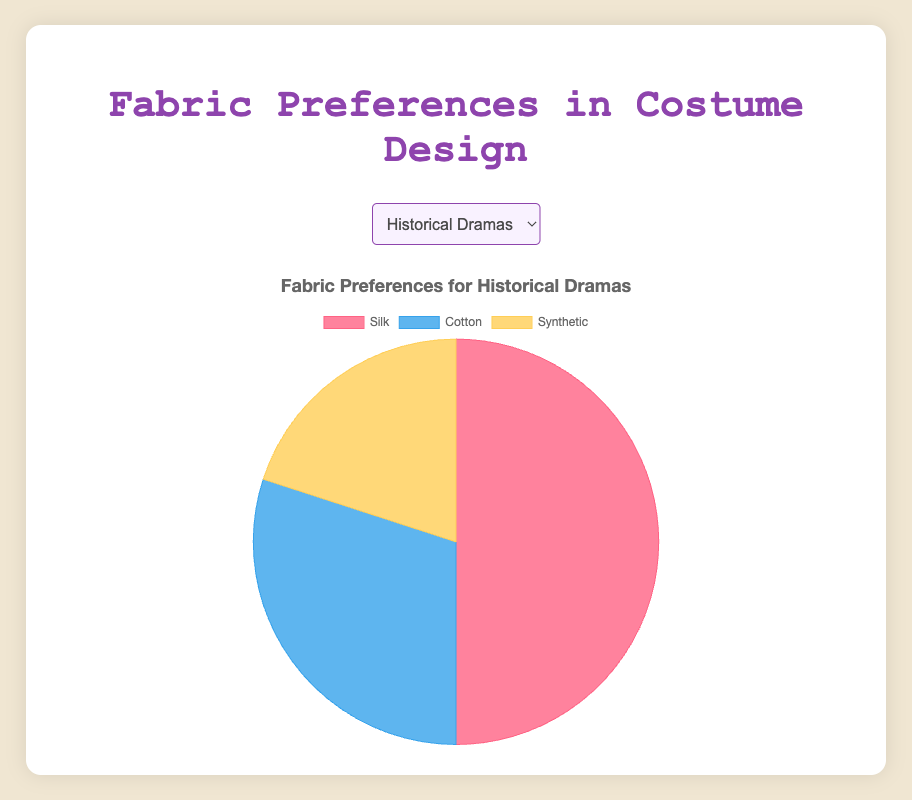Which fabric material is preferred the most in Historical Dramas? By examining the pie chart for Historical Dramas, we can see that the largest portion is for Silk at 50%.
Answer: Silk For Romantic Films, how does the use of Cotton compare to the use of Silk? Comparing the proportions in the pie chart for Romantic Films, Cotton is at 35% while Silk is slightly higher at 40%.
Answer: Silk is higher In Action Films, if we combine the preferences for Silk and Cotton, how does this compare to the preference for Synthetic fabrics? Silk is at 10% and Cotton at 15%. Combining these results in 10 + 15 = 25%, which is much lower than the 75% preference for Synthetic.
Answer: 25% is lower than 75% What is the average percentage preference for Silk across all genres? Summing up the Silk values: 50 + 20 + 40 + 10 + 60 + 15 = 195. There are 6 genres, so the average is 195 / 6 = 32.5%.
Answer: 32.5% In which genre is there an equal preference for Cotton and Silk? In Science Fiction, the preferences for both Silk and Cotton are equal at 20%.
Answer: Science Fiction Which genre has the highest preference for Synthetic fabrics? By looking through all the pie charts, the highest preference for Synthetic is in Action Films at 75%.
Answer: Action Films What is the total percentage of Synthetic fabric preference in the Fantasy and Horror genres combined? Adding the Synthetic values for Fantasy (30%) and Horror (60%), we get 30 + 60 = 90%.
Answer: 90% How does the preference for Synthetic fabrics in Horror Films compare to that in Science Fiction? In Horror Films, the preference for Synthetic fabrics is 60%, which is equal to the 60% in Science Fiction.
Answer: They are equal Which fabric color represents Silk in the pie charts? The visual representation shows Silk in red.
Answer: Red For Historical Dramas, what is the difference between the fabric preferences for Silk and Synthetic? Silk has a 50% preference while Synthetic has 20%, resulting in a difference of 50 - 20 = 30%.
Answer: 30% 